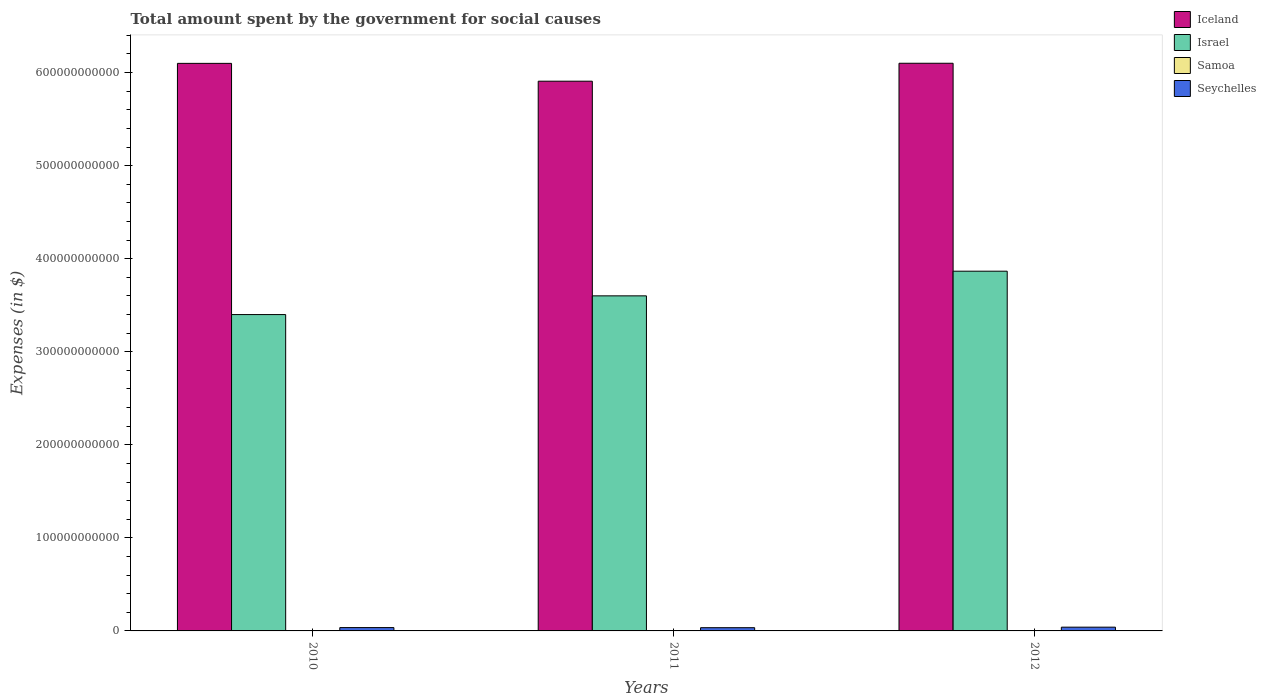Are the number of bars per tick equal to the number of legend labels?
Your answer should be very brief. Yes. Are the number of bars on each tick of the X-axis equal?
Make the answer very short. Yes. How many bars are there on the 1st tick from the right?
Give a very brief answer. 4. In how many cases, is the number of bars for a given year not equal to the number of legend labels?
Make the answer very short. 0. What is the amount spent for social causes by the government in Israel in 2011?
Make the answer very short. 3.60e+11. Across all years, what is the maximum amount spent for social causes by the government in Samoa?
Provide a succinct answer. 4.53e+05. Across all years, what is the minimum amount spent for social causes by the government in Samoa?
Provide a succinct answer. 4.32e+05. In which year was the amount spent for social causes by the government in Samoa maximum?
Ensure brevity in your answer.  2012. In which year was the amount spent for social causes by the government in Seychelles minimum?
Make the answer very short. 2011. What is the total amount spent for social causes by the government in Seychelles in the graph?
Your answer should be very brief. 1.11e+1. What is the difference between the amount spent for social causes by the government in Seychelles in 2011 and that in 2012?
Provide a short and direct response. -5.65e+08. What is the difference between the amount spent for social causes by the government in Seychelles in 2011 and the amount spent for social causes by the government in Iceland in 2012?
Keep it short and to the point. -6.07e+11. What is the average amount spent for social causes by the government in Seychelles per year?
Offer a terse response. 3.70e+09. In the year 2010, what is the difference between the amount spent for social causes by the government in Seychelles and amount spent for social causes by the government in Samoa?
Make the answer very short. 3.58e+09. In how many years, is the amount spent for social causes by the government in Iceland greater than 580000000000 $?
Give a very brief answer. 3. What is the ratio of the amount spent for social causes by the government in Israel in 2010 to that in 2012?
Keep it short and to the point. 0.88. What is the difference between the highest and the second highest amount spent for social causes by the government in Iceland?
Give a very brief answer. 1.12e+08. What is the difference between the highest and the lowest amount spent for social causes by the government in Iceland?
Provide a succinct answer. 1.93e+1. Is the sum of the amount spent for social causes by the government in Samoa in 2011 and 2012 greater than the maximum amount spent for social causes by the government in Israel across all years?
Provide a short and direct response. No. What does the 3rd bar from the left in 2012 represents?
Provide a succinct answer. Samoa. What does the 1st bar from the right in 2011 represents?
Make the answer very short. Seychelles. Is it the case that in every year, the sum of the amount spent for social causes by the government in Samoa and amount spent for social causes by the government in Iceland is greater than the amount spent for social causes by the government in Israel?
Provide a succinct answer. Yes. How many bars are there?
Offer a terse response. 12. What is the difference between two consecutive major ticks on the Y-axis?
Give a very brief answer. 1.00e+11. Are the values on the major ticks of Y-axis written in scientific E-notation?
Your answer should be compact. No. Where does the legend appear in the graph?
Provide a succinct answer. Top right. How many legend labels are there?
Ensure brevity in your answer.  4. What is the title of the graph?
Ensure brevity in your answer.  Total amount spent by the government for social causes. Does "Bolivia" appear as one of the legend labels in the graph?
Offer a terse response. No. What is the label or title of the Y-axis?
Provide a succinct answer. Expenses (in $). What is the Expenses (in $) of Iceland in 2010?
Your response must be concise. 6.10e+11. What is the Expenses (in $) in Israel in 2010?
Your answer should be very brief. 3.40e+11. What is the Expenses (in $) in Samoa in 2010?
Your answer should be compact. 4.32e+05. What is the Expenses (in $) of Seychelles in 2010?
Ensure brevity in your answer.  3.59e+09. What is the Expenses (in $) in Iceland in 2011?
Ensure brevity in your answer.  5.91e+11. What is the Expenses (in $) in Israel in 2011?
Offer a very short reply. 3.60e+11. What is the Expenses (in $) in Samoa in 2011?
Offer a terse response. 4.53e+05. What is the Expenses (in $) in Seychelles in 2011?
Ensure brevity in your answer.  3.47e+09. What is the Expenses (in $) of Iceland in 2012?
Your response must be concise. 6.10e+11. What is the Expenses (in $) of Israel in 2012?
Provide a short and direct response. 3.87e+11. What is the Expenses (in $) in Samoa in 2012?
Make the answer very short. 4.53e+05. What is the Expenses (in $) in Seychelles in 2012?
Provide a short and direct response. 4.04e+09. Across all years, what is the maximum Expenses (in $) of Iceland?
Offer a terse response. 6.10e+11. Across all years, what is the maximum Expenses (in $) in Israel?
Give a very brief answer. 3.87e+11. Across all years, what is the maximum Expenses (in $) of Samoa?
Offer a terse response. 4.53e+05. Across all years, what is the maximum Expenses (in $) of Seychelles?
Offer a terse response. 4.04e+09. Across all years, what is the minimum Expenses (in $) in Iceland?
Your answer should be very brief. 5.91e+11. Across all years, what is the minimum Expenses (in $) of Israel?
Your answer should be compact. 3.40e+11. Across all years, what is the minimum Expenses (in $) in Samoa?
Keep it short and to the point. 4.32e+05. Across all years, what is the minimum Expenses (in $) of Seychelles?
Ensure brevity in your answer.  3.47e+09. What is the total Expenses (in $) of Iceland in the graph?
Your answer should be compact. 1.81e+12. What is the total Expenses (in $) of Israel in the graph?
Keep it short and to the point. 1.09e+12. What is the total Expenses (in $) in Samoa in the graph?
Your response must be concise. 1.34e+06. What is the total Expenses (in $) in Seychelles in the graph?
Offer a very short reply. 1.11e+1. What is the difference between the Expenses (in $) in Iceland in 2010 and that in 2011?
Ensure brevity in your answer.  1.92e+1. What is the difference between the Expenses (in $) in Israel in 2010 and that in 2011?
Your response must be concise. -2.01e+1. What is the difference between the Expenses (in $) in Samoa in 2010 and that in 2011?
Provide a succinct answer. -2.12e+04. What is the difference between the Expenses (in $) of Seychelles in 2010 and that in 2011?
Provide a short and direct response. 1.15e+08. What is the difference between the Expenses (in $) of Iceland in 2010 and that in 2012?
Your response must be concise. -1.12e+08. What is the difference between the Expenses (in $) in Israel in 2010 and that in 2012?
Your answer should be very brief. -4.66e+1. What is the difference between the Expenses (in $) of Samoa in 2010 and that in 2012?
Your answer should be compact. -2.12e+04. What is the difference between the Expenses (in $) in Seychelles in 2010 and that in 2012?
Provide a short and direct response. -4.50e+08. What is the difference between the Expenses (in $) in Iceland in 2011 and that in 2012?
Your answer should be very brief. -1.93e+1. What is the difference between the Expenses (in $) in Israel in 2011 and that in 2012?
Offer a terse response. -2.65e+1. What is the difference between the Expenses (in $) in Samoa in 2011 and that in 2012?
Your answer should be compact. -5.38. What is the difference between the Expenses (in $) of Seychelles in 2011 and that in 2012?
Your response must be concise. -5.65e+08. What is the difference between the Expenses (in $) of Iceland in 2010 and the Expenses (in $) of Israel in 2011?
Provide a succinct answer. 2.50e+11. What is the difference between the Expenses (in $) of Iceland in 2010 and the Expenses (in $) of Samoa in 2011?
Offer a terse response. 6.10e+11. What is the difference between the Expenses (in $) of Iceland in 2010 and the Expenses (in $) of Seychelles in 2011?
Provide a short and direct response. 6.06e+11. What is the difference between the Expenses (in $) of Israel in 2010 and the Expenses (in $) of Samoa in 2011?
Give a very brief answer. 3.40e+11. What is the difference between the Expenses (in $) in Israel in 2010 and the Expenses (in $) in Seychelles in 2011?
Your answer should be very brief. 3.36e+11. What is the difference between the Expenses (in $) of Samoa in 2010 and the Expenses (in $) of Seychelles in 2011?
Keep it short and to the point. -3.47e+09. What is the difference between the Expenses (in $) in Iceland in 2010 and the Expenses (in $) in Israel in 2012?
Provide a short and direct response. 2.23e+11. What is the difference between the Expenses (in $) in Iceland in 2010 and the Expenses (in $) in Samoa in 2012?
Provide a succinct answer. 6.10e+11. What is the difference between the Expenses (in $) in Iceland in 2010 and the Expenses (in $) in Seychelles in 2012?
Offer a very short reply. 6.06e+11. What is the difference between the Expenses (in $) in Israel in 2010 and the Expenses (in $) in Samoa in 2012?
Offer a very short reply. 3.40e+11. What is the difference between the Expenses (in $) of Israel in 2010 and the Expenses (in $) of Seychelles in 2012?
Give a very brief answer. 3.36e+11. What is the difference between the Expenses (in $) in Samoa in 2010 and the Expenses (in $) in Seychelles in 2012?
Offer a very short reply. -4.04e+09. What is the difference between the Expenses (in $) in Iceland in 2011 and the Expenses (in $) in Israel in 2012?
Ensure brevity in your answer.  2.04e+11. What is the difference between the Expenses (in $) in Iceland in 2011 and the Expenses (in $) in Samoa in 2012?
Give a very brief answer. 5.91e+11. What is the difference between the Expenses (in $) of Iceland in 2011 and the Expenses (in $) of Seychelles in 2012?
Offer a terse response. 5.87e+11. What is the difference between the Expenses (in $) in Israel in 2011 and the Expenses (in $) in Samoa in 2012?
Your answer should be very brief. 3.60e+11. What is the difference between the Expenses (in $) of Israel in 2011 and the Expenses (in $) of Seychelles in 2012?
Your answer should be compact. 3.56e+11. What is the difference between the Expenses (in $) in Samoa in 2011 and the Expenses (in $) in Seychelles in 2012?
Make the answer very short. -4.04e+09. What is the average Expenses (in $) of Iceland per year?
Ensure brevity in your answer.  6.04e+11. What is the average Expenses (in $) of Israel per year?
Give a very brief answer. 3.62e+11. What is the average Expenses (in $) in Samoa per year?
Offer a very short reply. 4.46e+05. What is the average Expenses (in $) of Seychelles per year?
Ensure brevity in your answer.  3.70e+09. In the year 2010, what is the difference between the Expenses (in $) of Iceland and Expenses (in $) of Israel?
Provide a succinct answer. 2.70e+11. In the year 2010, what is the difference between the Expenses (in $) in Iceland and Expenses (in $) in Samoa?
Offer a terse response. 6.10e+11. In the year 2010, what is the difference between the Expenses (in $) in Iceland and Expenses (in $) in Seychelles?
Provide a succinct answer. 6.06e+11. In the year 2010, what is the difference between the Expenses (in $) in Israel and Expenses (in $) in Samoa?
Your answer should be compact. 3.40e+11. In the year 2010, what is the difference between the Expenses (in $) in Israel and Expenses (in $) in Seychelles?
Provide a short and direct response. 3.36e+11. In the year 2010, what is the difference between the Expenses (in $) of Samoa and Expenses (in $) of Seychelles?
Keep it short and to the point. -3.58e+09. In the year 2011, what is the difference between the Expenses (in $) in Iceland and Expenses (in $) in Israel?
Ensure brevity in your answer.  2.31e+11. In the year 2011, what is the difference between the Expenses (in $) in Iceland and Expenses (in $) in Samoa?
Give a very brief answer. 5.91e+11. In the year 2011, what is the difference between the Expenses (in $) of Iceland and Expenses (in $) of Seychelles?
Provide a short and direct response. 5.87e+11. In the year 2011, what is the difference between the Expenses (in $) in Israel and Expenses (in $) in Samoa?
Ensure brevity in your answer.  3.60e+11. In the year 2011, what is the difference between the Expenses (in $) of Israel and Expenses (in $) of Seychelles?
Your answer should be very brief. 3.57e+11. In the year 2011, what is the difference between the Expenses (in $) in Samoa and Expenses (in $) in Seychelles?
Provide a succinct answer. -3.47e+09. In the year 2012, what is the difference between the Expenses (in $) of Iceland and Expenses (in $) of Israel?
Provide a succinct answer. 2.23e+11. In the year 2012, what is the difference between the Expenses (in $) of Iceland and Expenses (in $) of Samoa?
Offer a very short reply. 6.10e+11. In the year 2012, what is the difference between the Expenses (in $) in Iceland and Expenses (in $) in Seychelles?
Ensure brevity in your answer.  6.06e+11. In the year 2012, what is the difference between the Expenses (in $) in Israel and Expenses (in $) in Samoa?
Give a very brief answer. 3.87e+11. In the year 2012, what is the difference between the Expenses (in $) in Israel and Expenses (in $) in Seychelles?
Offer a very short reply. 3.83e+11. In the year 2012, what is the difference between the Expenses (in $) of Samoa and Expenses (in $) of Seychelles?
Keep it short and to the point. -4.04e+09. What is the ratio of the Expenses (in $) of Iceland in 2010 to that in 2011?
Keep it short and to the point. 1.03. What is the ratio of the Expenses (in $) of Israel in 2010 to that in 2011?
Offer a very short reply. 0.94. What is the ratio of the Expenses (in $) of Samoa in 2010 to that in 2011?
Ensure brevity in your answer.  0.95. What is the ratio of the Expenses (in $) of Seychelles in 2010 to that in 2011?
Your response must be concise. 1.03. What is the ratio of the Expenses (in $) in Iceland in 2010 to that in 2012?
Make the answer very short. 1. What is the ratio of the Expenses (in $) of Israel in 2010 to that in 2012?
Offer a very short reply. 0.88. What is the ratio of the Expenses (in $) in Samoa in 2010 to that in 2012?
Your response must be concise. 0.95. What is the ratio of the Expenses (in $) in Seychelles in 2010 to that in 2012?
Offer a very short reply. 0.89. What is the ratio of the Expenses (in $) in Iceland in 2011 to that in 2012?
Your response must be concise. 0.97. What is the ratio of the Expenses (in $) in Israel in 2011 to that in 2012?
Your response must be concise. 0.93. What is the ratio of the Expenses (in $) in Samoa in 2011 to that in 2012?
Keep it short and to the point. 1. What is the ratio of the Expenses (in $) in Seychelles in 2011 to that in 2012?
Provide a succinct answer. 0.86. What is the difference between the highest and the second highest Expenses (in $) of Iceland?
Provide a short and direct response. 1.12e+08. What is the difference between the highest and the second highest Expenses (in $) of Israel?
Keep it short and to the point. 2.65e+1. What is the difference between the highest and the second highest Expenses (in $) in Samoa?
Provide a short and direct response. 5.38. What is the difference between the highest and the second highest Expenses (in $) in Seychelles?
Provide a succinct answer. 4.50e+08. What is the difference between the highest and the lowest Expenses (in $) in Iceland?
Make the answer very short. 1.93e+1. What is the difference between the highest and the lowest Expenses (in $) of Israel?
Give a very brief answer. 4.66e+1. What is the difference between the highest and the lowest Expenses (in $) of Samoa?
Your answer should be very brief. 2.12e+04. What is the difference between the highest and the lowest Expenses (in $) of Seychelles?
Keep it short and to the point. 5.65e+08. 